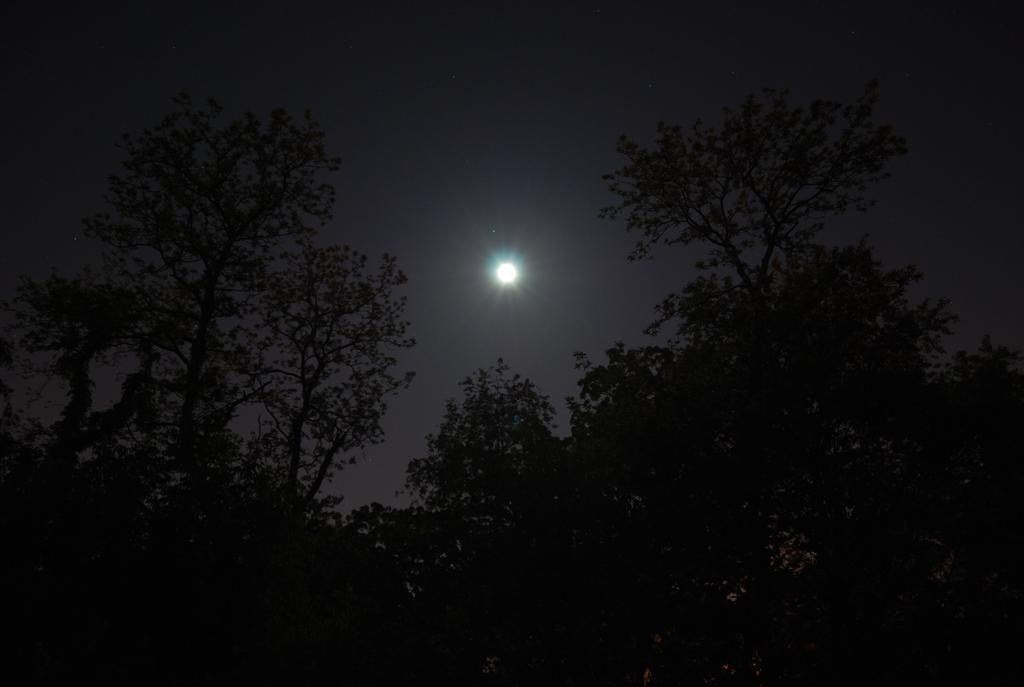What celestial body can be seen in the sky in the image? There is a moon in the sky in the image. What type of vegetation is visible in the image? There are trees visible in the image. What thought is the governor having while sailing in the image? There is no governor or sailing activity present in the image; it features a moon and trees. 